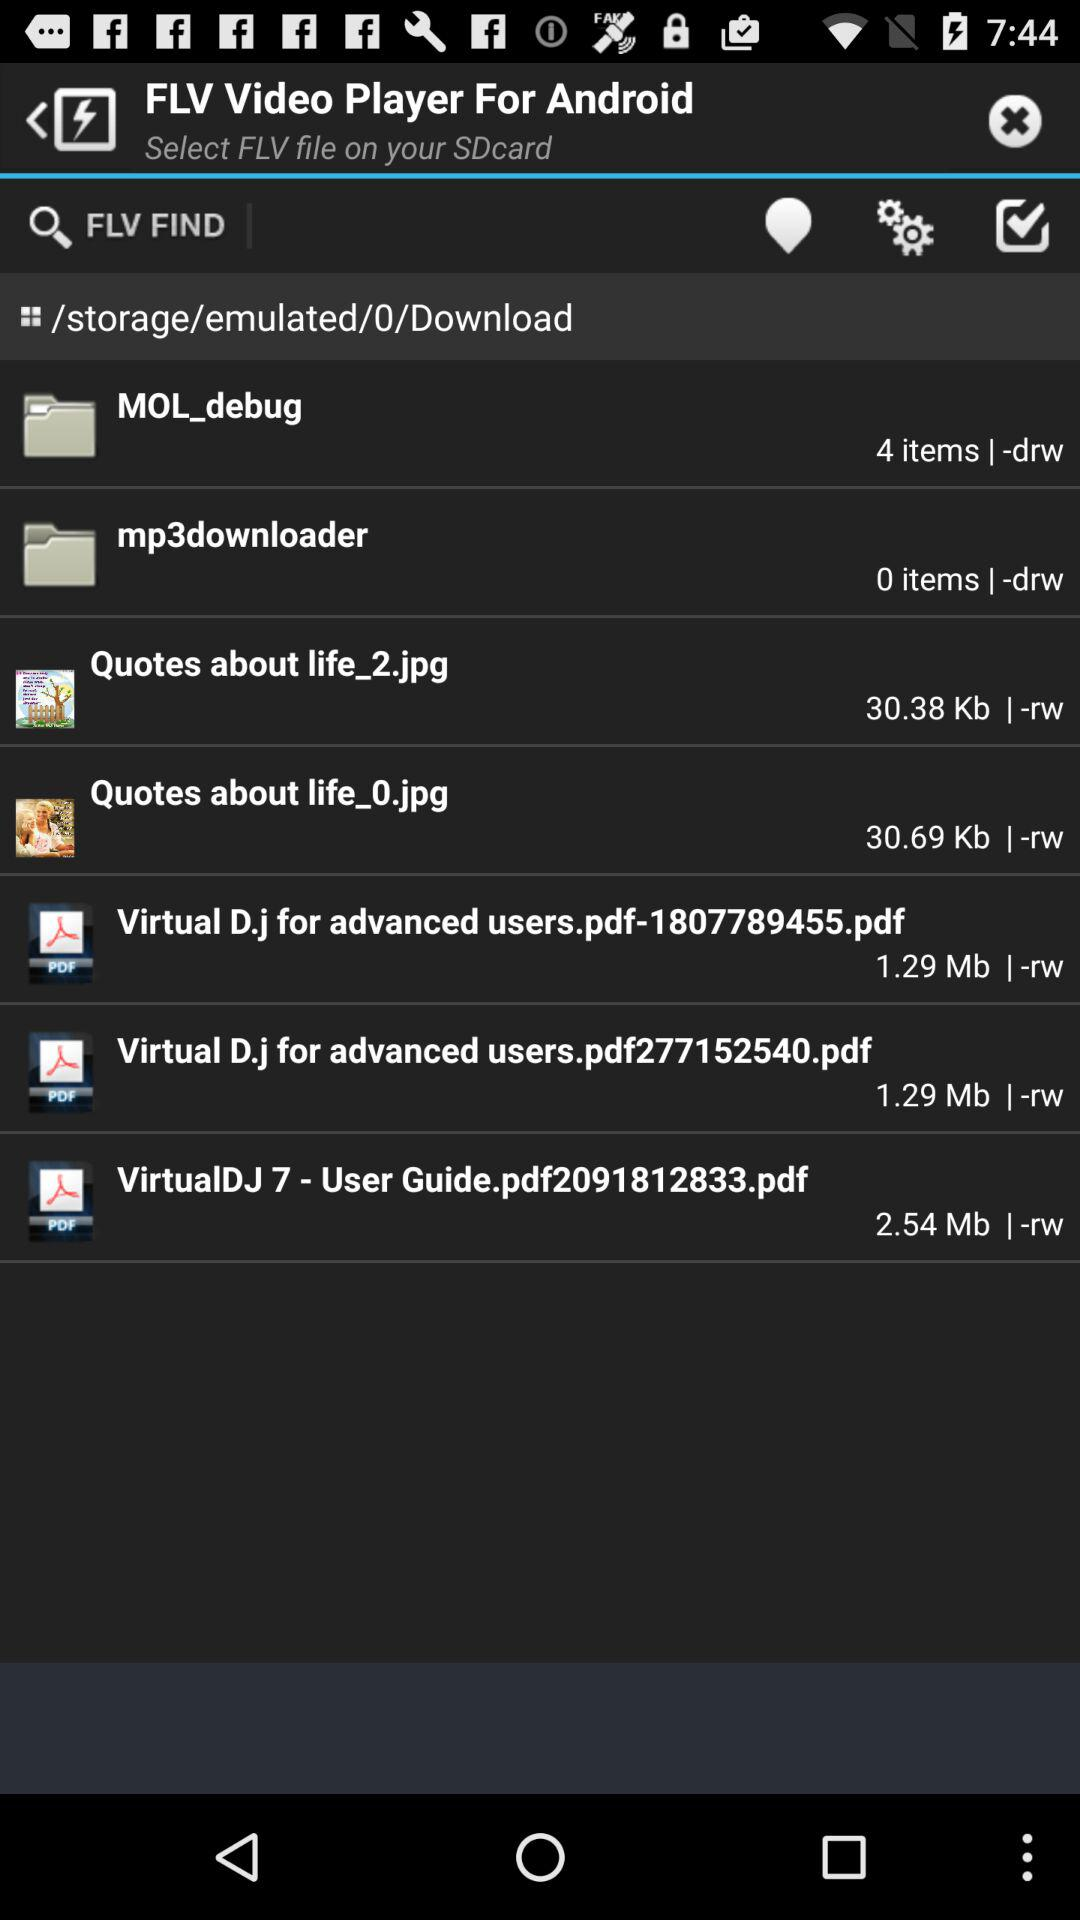What is the size of "Quotes about life_2.jpg"? The size is 30.38 kb. 